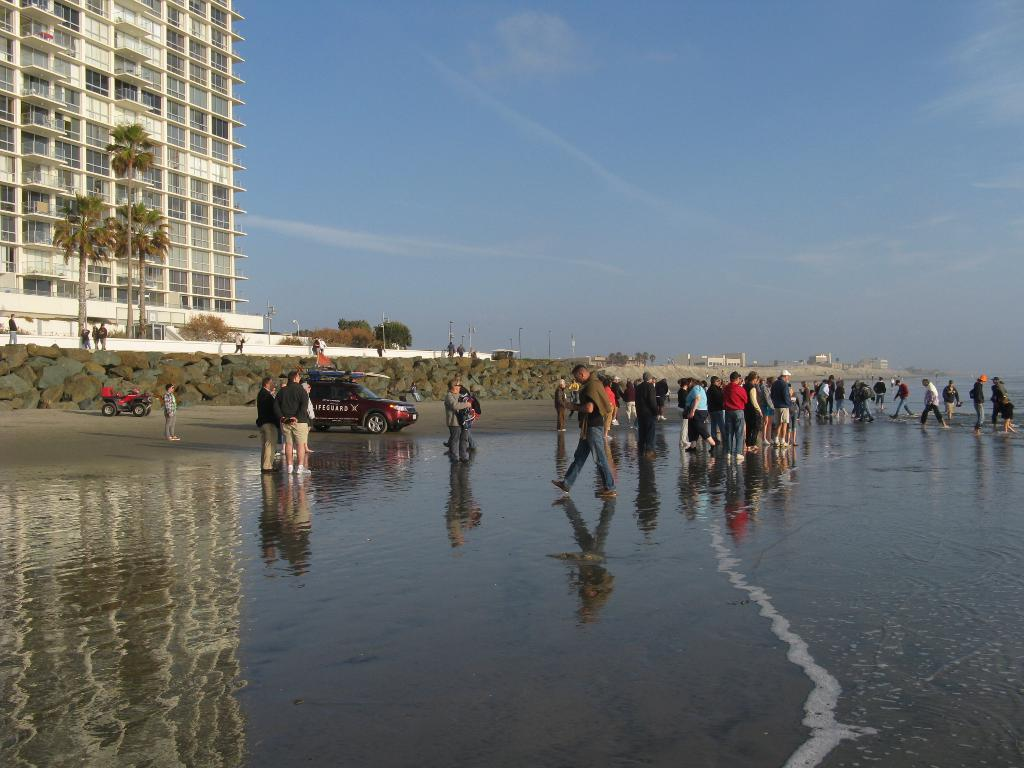What is visible in the image? Water, people, vehicles, rocks, buildings, poles, trees, and the sky are visible in the image. Can you describe the setting in which the people and vehicles are located? The setting includes water, rocks, buildings, poles, and trees. What type of structures can be seen in the image? Buildings and poles can be seen in the image. What is the natural environment visible in the image? The natural environment includes water, rocks, and trees. Can you tell me how many trees the horse is standing next to in the image? There is no horse present in the image, so it is not possible to answer that question. 